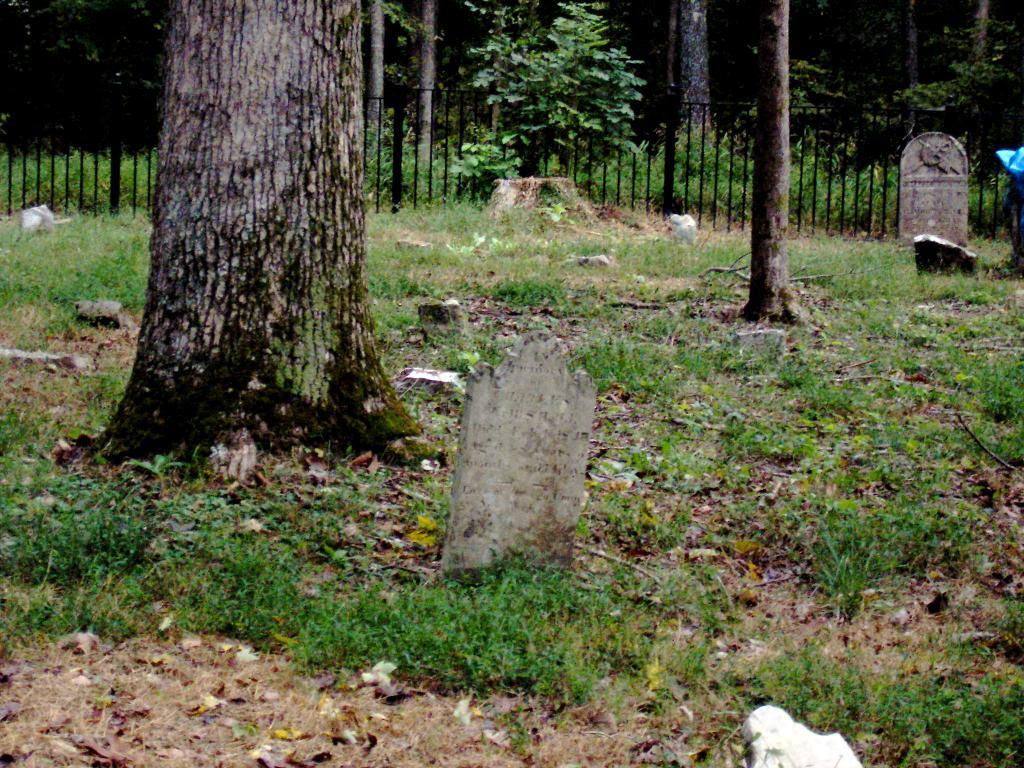What type of vegetation is visible in the image? There is grass in the image. What type of structures can be seen in the image? There are walls and a fence in the image. What type of natural elements are present in the image? There are trees in the image. Can you tell me how many times the person in the image shakes their knee? There is no person present in the image, so it is not possible to determine how many times they might shake their knee. Is the person in the image wearing skates? There is no person present in the image, so it is not possible to determine if they are wearing skates. 